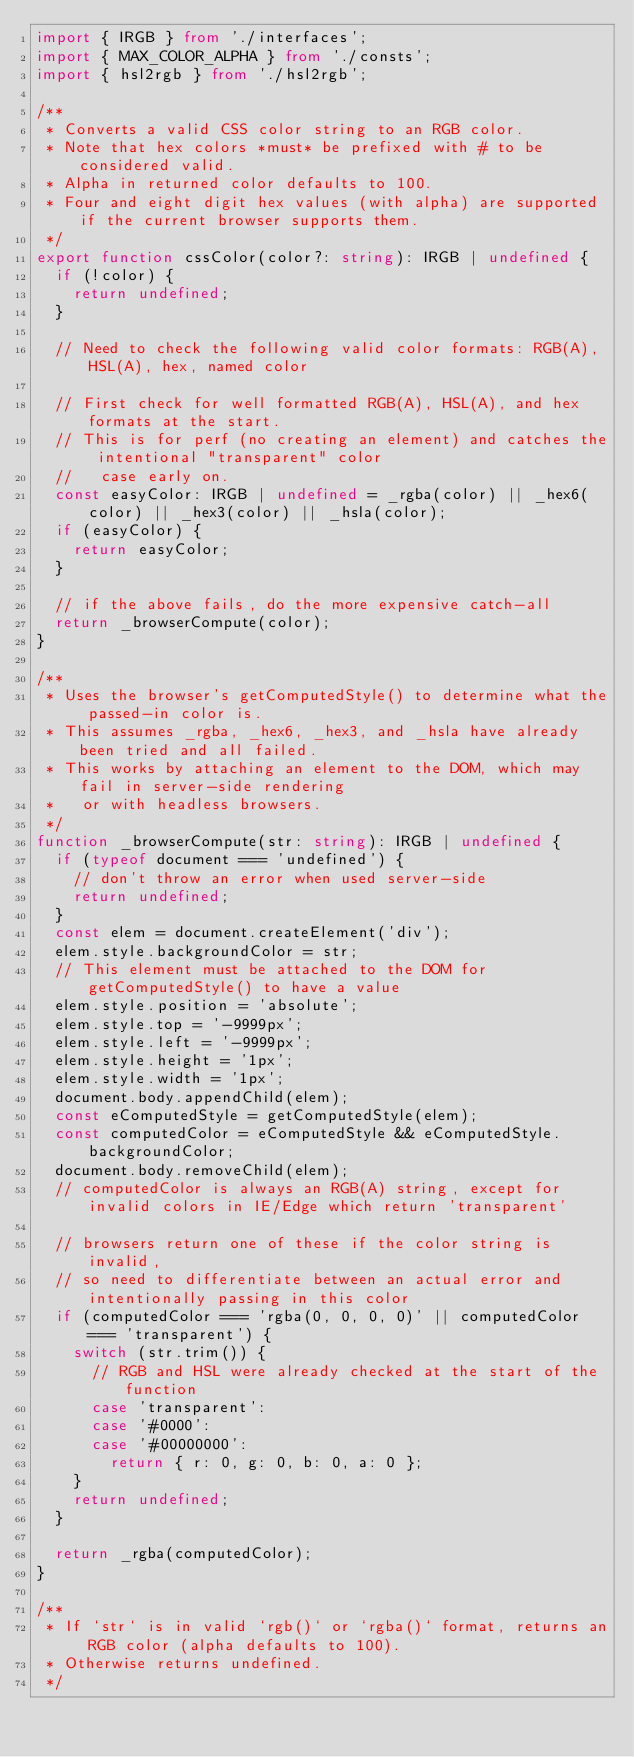Convert code to text. <code><loc_0><loc_0><loc_500><loc_500><_TypeScript_>import { IRGB } from './interfaces';
import { MAX_COLOR_ALPHA } from './consts';
import { hsl2rgb } from './hsl2rgb';

/**
 * Converts a valid CSS color string to an RGB color.
 * Note that hex colors *must* be prefixed with # to be considered valid.
 * Alpha in returned color defaults to 100.
 * Four and eight digit hex values (with alpha) are supported if the current browser supports them.
 */
export function cssColor(color?: string): IRGB | undefined {
  if (!color) {
    return undefined;
  }

  // Need to check the following valid color formats: RGB(A), HSL(A), hex, named color

  // First check for well formatted RGB(A), HSL(A), and hex formats at the start.
  // This is for perf (no creating an element) and catches the intentional "transparent" color
  //   case early on.
  const easyColor: IRGB | undefined = _rgba(color) || _hex6(color) || _hex3(color) || _hsla(color);
  if (easyColor) {
    return easyColor;
  }

  // if the above fails, do the more expensive catch-all
  return _browserCompute(color);
}

/**
 * Uses the browser's getComputedStyle() to determine what the passed-in color is.
 * This assumes _rgba, _hex6, _hex3, and _hsla have already been tried and all failed.
 * This works by attaching an element to the DOM, which may fail in server-side rendering
 *   or with headless browsers.
 */
function _browserCompute(str: string): IRGB | undefined {
  if (typeof document === 'undefined') {
    // don't throw an error when used server-side
    return undefined;
  }
  const elem = document.createElement('div');
  elem.style.backgroundColor = str;
  // This element must be attached to the DOM for getComputedStyle() to have a value
  elem.style.position = 'absolute';
  elem.style.top = '-9999px';
  elem.style.left = '-9999px';
  elem.style.height = '1px';
  elem.style.width = '1px';
  document.body.appendChild(elem);
  const eComputedStyle = getComputedStyle(elem);
  const computedColor = eComputedStyle && eComputedStyle.backgroundColor;
  document.body.removeChild(elem);
  // computedColor is always an RGB(A) string, except for invalid colors in IE/Edge which return 'transparent'

  // browsers return one of these if the color string is invalid,
  // so need to differentiate between an actual error and intentionally passing in this color
  if (computedColor === 'rgba(0, 0, 0, 0)' || computedColor === 'transparent') {
    switch (str.trim()) {
      // RGB and HSL were already checked at the start of the function
      case 'transparent':
      case '#0000':
      case '#00000000':
        return { r: 0, g: 0, b: 0, a: 0 };
    }
    return undefined;
  }

  return _rgba(computedColor);
}

/**
 * If `str` is in valid `rgb()` or `rgba()` format, returns an RGB color (alpha defaults to 100).
 * Otherwise returns undefined.
 */</code> 